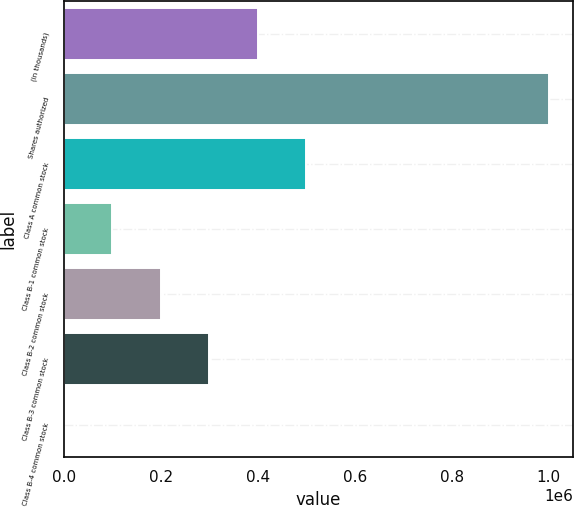Convert chart. <chart><loc_0><loc_0><loc_500><loc_500><bar_chart><fcel>(in thousands)<fcel>Shares authorized<fcel>Class A common stock<fcel>Class B-1 common stock<fcel>Class B-2 common stock<fcel>Class B-3 common stock<fcel>Class B-4 common stock<nl><fcel>400000<fcel>1e+06<fcel>500000<fcel>100000<fcel>200000<fcel>300000<fcel>0.4<nl></chart> 